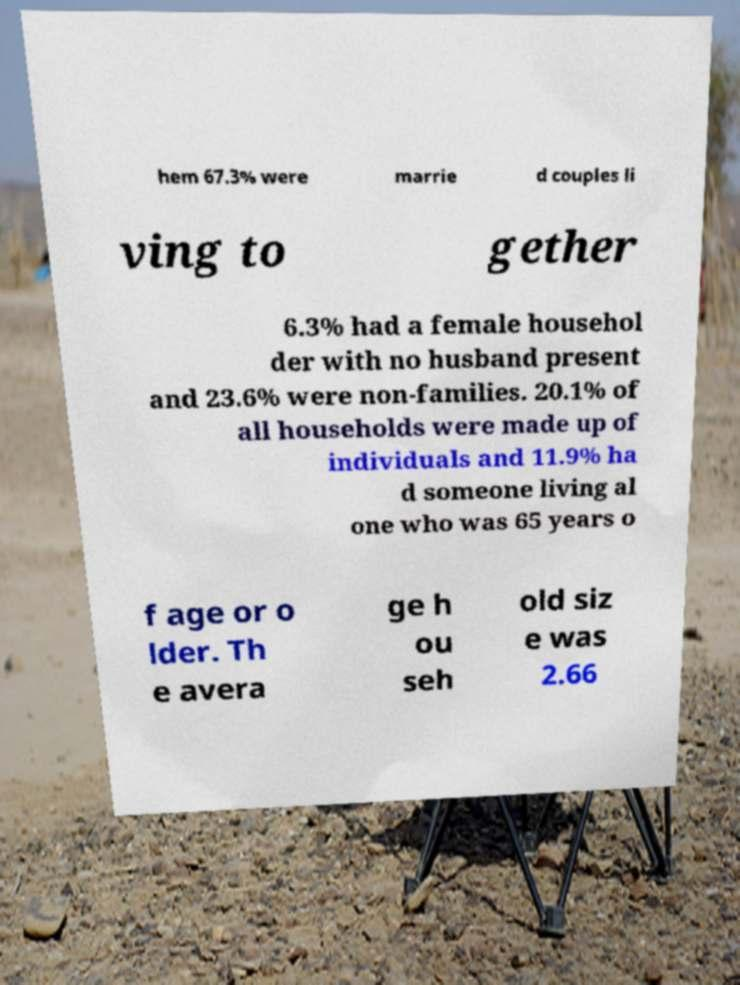Can you accurately transcribe the text from the provided image for me? hem 67.3% were marrie d couples li ving to gether 6.3% had a female househol der with no husband present and 23.6% were non-families. 20.1% of all households were made up of individuals and 11.9% ha d someone living al one who was 65 years o f age or o lder. Th e avera ge h ou seh old siz e was 2.66 